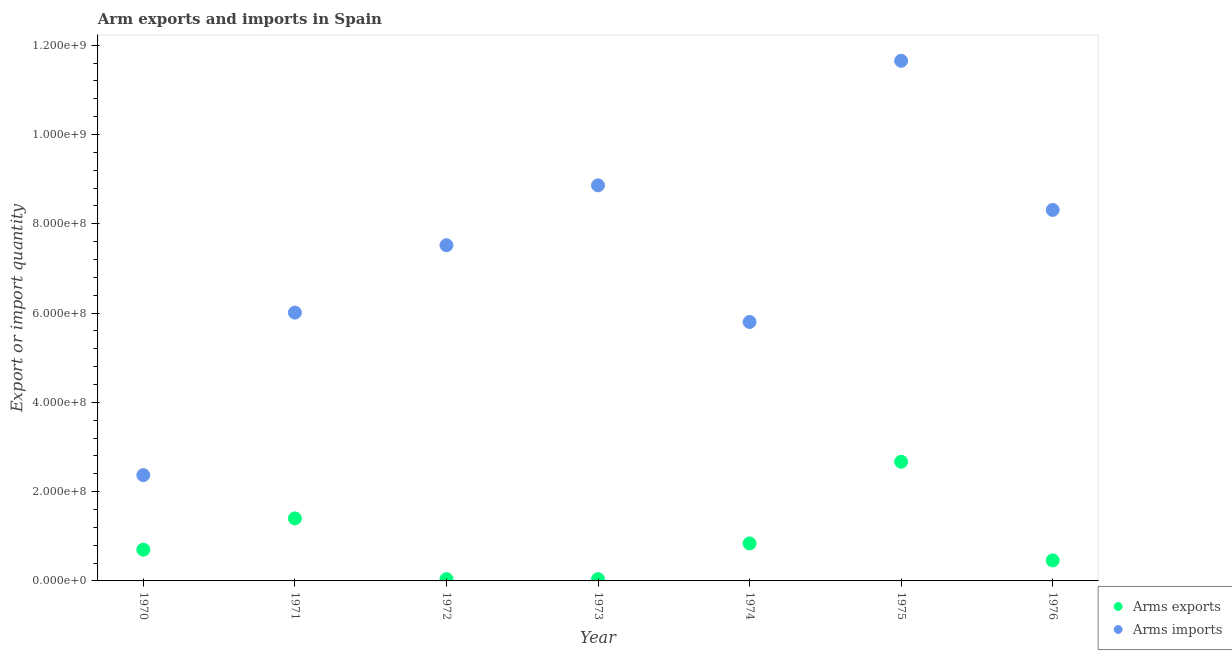Is the number of dotlines equal to the number of legend labels?
Your answer should be very brief. Yes. What is the arms exports in 1976?
Give a very brief answer. 4.60e+07. Across all years, what is the maximum arms imports?
Your answer should be very brief. 1.16e+09. Across all years, what is the minimum arms imports?
Your answer should be very brief. 2.37e+08. In which year was the arms imports maximum?
Give a very brief answer. 1975. What is the total arms exports in the graph?
Provide a short and direct response. 6.15e+08. What is the difference between the arms imports in 1972 and that in 1975?
Provide a succinct answer. -4.13e+08. What is the difference between the arms imports in 1973 and the arms exports in 1971?
Provide a short and direct response. 7.46e+08. What is the average arms imports per year?
Keep it short and to the point. 7.22e+08. In the year 1976, what is the difference between the arms imports and arms exports?
Make the answer very short. 7.85e+08. In how many years, is the arms imports greater than 440000000?
Offer a very short reply. 6. What is the ratio of the arms imports in 1972 to that in 1975?
Keep it short and to the point. 0.65. Is the arms exports in 1970 less than that in 1973?
Offer a very short reply. No. Is the difference between the arms imports in 1971 and 1976 greater than the difference between the arms exports in 1971 and 1976?
Provide a short and direct response. No. What is the difference between the highest and the second highest arms exports?
Your answer should be very brief. 1.27e+08. What is the difference between the highest and the lowest arms exports?
Your answer should be compact. 2.63e+08. In how many years, is the arms exports greater than the average arms exports taken over all years?
Provide a short and direct response. 2. Is the arms exports strictly less than the arms imports over the years?
Your answer should be compact. Yes. What is the difference between two consecutive major ticks on the Y-axis?
Your response must be concise. 2.00e+08. Are the values on the major ticks of Y-axis written in scientific E-notation?
Your answer should be compact. Yes. Where does the legend appear in the graph?
Your answer should be very brief. Bottom right. How are the legend labels stacked?
Your answer should be very brief. Vertical. What is the title of the graph?
Provide a succinct answer. Arm exports and imports in Spain. What is the label or title of the Y-axis?
Ensure brevity in your answer.  Export or import quantity. What is the Export or import quantity in Arms exports in 1970?
Give a very brief answer. 7.00e+07. What is the Export or import quantity of Arms imports in 1970?
Your response must be concise. 2.37e+08. What is the Export or import quantity of Arms exports in 1971?
Provide a short and direct response. 1.40e+08. What is the Export or import quantity in Arms imports in 1971?
Your answer should be very brief. 6.01e+08. What is the Export or import quantity of Arms imports in 1972?
Offer a very short reply. 7.52e+08. What is the Export or import quantity of Arms exports in 1973?
Offer a terse response. 4.00e+06. What is the Export or import quantity in Arms imports in 1973?
Make the answer very short. 8.86e+08. What is the Export or import quantity in Arms exports in 1974?
Keep it short and to the point. 8.40e+07. What is the Export or import quantity in Arms imports in 1974?
Ensure brevity in your answer.  5.80e+08. What is the Export or import quantity in Arms exports in 1975?
Your answer should be very brief. 2.67e+08. What is the Export or import quantity of Arms imports in 1975?
Give a very brief answer. 1.16e+09. What is the Export or import quantity in Arms exports in 1976?
Your answer should be very brief. 4.60e+07. What is the Export or import quantity of Arms imports in 1976?
Provide a short and direct response. 8.31e+08. Across all years, what is the maximum Export or import quantity in Arms exports?
Your answer should be compact. 2.67e+08. Across all years, what is the maximum Export or import quantity of Arms imports?
Offer a terse response. 1.16e+09. Across all years, what is the minimum Export or import quantity of Arms exports?
Your answer should be compact. 4.00e+06. Across all years, what is the minimum Export or import quantity of Arms imports?
Keep it short and to the point. 2.37e+08. What is the total Export or import quantity of Arms exports in the graph?
Offer a terse response. 6.15e+08. What is the total Export or import quantity of Arms imports in the graph?
Provide a short and direct response. 5.05e+09. What is the difference between the Export or import quantity in Arms exports in 1970 and that in 1971?
Your answer should be very brief. -7.00e+07. What is the difference between the Export or import quantity of Arms imports in 1970 and that in 1971?
Offer a terse response. -3.64e+08. What is the difference between the Export or import quantity of Arms exports in 1970 and that in 1972?
Make the answer very short. 6.60e+07. What is the difference between the Export or import quantity in Arms imports in 1970 and that in 1972?
Provide a succinct answer. -5.15e+08. What is the difference between the Export or import quantity of Arms exports in 1970 and that in 1973?
Your answer should be very brief. 6.60e+07. What is the difference between the Export or import quantity of Arms imports in 1970 and that in 1973?
Offer a terse response. -6.49e+08. What is the difference between the Export or import quantity of Arms exports in 1970 and that in 1974?
Keep it short and to the point. -1.40e+07. What is the difference between the Export or import quantity of Arms imports in 1970 and that in 1974?
Provide a succinct answer. -3.43e+08. What is the difference between the Export or import quantity in Arms exports in 1970 and that in 1975?
Keep it short and to the point. -1.97e+08. What is the difference between the Export or import quantity of Arms imports in 1970 and that in 1975?
Your answer should be compact. -9.28e+08. What is the difference between the Export or import quantity in Arms exports in 1970 and that in 1976?
Offer a terse response. 2.40e+07. What is the difference between the Export or import quantity of Arms imports in 1970 and that in 1976?
Provide a succinct answer. -5.94e+08. What is the difference between the Export or import quantity in Arms exports in 1971 and that in 1972?
Make the answer very short. 1.36e+08. What is the difference between the Export or import quantity of Arms imports in 1971 and that in 1972?
Offer a very short reply. -1.51e+08. What is the difference between the Export or import quantity in Arms exports in 1971 and that in 1973?
Make the answer very short. 1.36e+08. What is the difference between the Export or import quantity in Arms imports in 1971 and that in 1973?
Make the answer very short. -2.85e+08. What is the difference between the Export or import quantity in Arms exports in 1971 and that in 1974?
Keep it short and to the point. 5.60e+07. What is the difference between the Export or import quantity of Arms imports in 1971 and that in 1974?
Your answer should be compact. 2.10e+07. What is the difference between the Export or import quantity in Arms exports in 1971 and that in 1975?
Provide a short and direct response. -1.27e+08. What is the difference between the Export or import quantity of Arms imports in 1971 and that in 1975?
Your answer should be compact. -5.64e+08. What is the difference between the Export or import quantity in Arms exports in 1971 and that in 1976?
Give a very brief answer. 9.40e+07. What is the difference between the Export or import quantity of Arms imports in 1971 and that in 1976?
Give a very brief answer. -2.30e+08. What is the difference between the Export or import quantity in Arms exports in 1972 and that in 1973?
Offer a very short reply. 0. What is the difference between the Export or import quantity in Arms imports in 1972 and that in 1973?
Your answer should be very brief. -1.34e+08. What is the difference between the Export or import quantity of Arms exports in 1972 and that in 1974?
Provide a succinct answer. -8.00e+07. What is the difference between the Export or import quantity of Arms imports in 1972 and that in 1974?
Keep it short and to the point. 1.72e+08. What is the difference between the Export or import quantity of Arms exports in 1972 and that in 1975?
Your response must be concise. -2.63e+08. What is the difference between the Export or import quantity in Arms imports in 1972 and that in 1975?
Offer a very short reply. -4.13e+08. What is the difference between the Export or import quantity in Arms exports in 1972 and that in 1976?
Your answer should be very brief. -4.20e+07. What is the difference between the Export or import quantity of Arms imports in 1972 and that in 1976?
Provide a succinct answer. -7.90e+07. What is the difference between the Export or import quantity in Arms exports in 1973 and that in 1974?
Keep it short and to the point. -8.00e+07. What is the difference between the Export or import quantity of Arms imports in 1973 and that in 1974?
Offer a terse response. 3.06e+08. What is the difference between the Export or import quantity in Arms exports in 1973 and that in 1975?
Offer a very short reply. -2.63e+08. What is the difference between the Export or import quantity in Arms imports in 1973 and that in 1975?
Your response must be concise. -2.79e+08. What is the difference between the Export or import quantity of Arms exports in 1973 and that in 1976?
Make the answer very short. -4.20e+07. What is the difference between the Export or import quantity of Arms imports in 1973 and that in 1976?
Give a very brief answer. 5.50e+07. What is the difference between the Export or import quantity in Arms exports in 1974 and that in 1975?
Keep it short and to the point. -1.83e+08. What is the difference between the Export or import quantity in Arms imports in 1974 and that in 1975?
Your answer should be compact. -5.85e+08. What is the difference between the Export or import quantity in Arms exports in 1974 and that in 1976?
Your answer should be compact. 3.80e+07. What is the difference between the Export or import quantity of Arms imports in 1974 and that in 1976?
Your answer should be compact. -2.51e+08. What is the difference between the Export or import quantity in Arms exports in 1975 and that in 1976?
Offer a very short reply. 2.21e+08. What is the difference between the Export or import quantity in Arms imports in 1975 and that in 1976?
Provide a succinct answer. 3.34e+08. What is the difference between the Export or import quantity of Arms exports in 1970 and the Export or import quantity of Arms imports in 1971?
Your answer should be very brief. -5.31e+08. What is the difference between the Export or import quantity in Arms exports in 1970 and the Export or import quantity in Arms imports in 1972?
Your answer should be very brief. -6.82e+08. What is the difference between the Export or import quantity of Arms exports in 1970 and the Export or import quantity of Arms imports in 1973?
Provide a short and direct response. -8.16e+08. What is the difference between the Export or import quantity of Arms exports in 1970 and the Export or import quantity of Arms imports in 1974?
Offer a very short reply. -5.10e+08. What is the difference between the Export or import quantity of Arms exports in 1970 and the Export or import quantity of Arms imports in 1975?
Provide a short and direct response. -1.10e+09. What is the difference between the Export or import quantity of Arms exports in 1970 and the Export or import quantity of Arms imports in 1976?
Keep it short and to the point. -7.61e+08. What is the difference between the Export or import quantity in Arms exports in 1971 and the Export or import quantity in Arms imports in 1972?
Provide a succinct answer. -6.12e+08. What is the difference between the Export or import quantity in Arms exports in 1971 and the Export or import quantity in Arms imports in 1973?
Give a very brief answer. -7.46e+08. What is the difference between the Export or import quantity in Arms exports in 1971 and the Export or import quantity in Arms imports in 1974?
Offer a terse response. -4.40e+08. What is the difference between the Export or import quantity of Arms exports in 1971 and the Export or import quantity of Arms imports in 1975?
Your answer should be compact. -1.02e+09. What is the difference between the Export or import quantity of Arms exports in 1971 and the Export or import quantity of Arms imports in 1976?
Provide a succinct answer. -6.91e+08. What is the difference between the Export or import quantity of Arms exports in 1972 and the Export or import quantity of Arms imports in 1973?
Your response must be concise. -8.82e+08. What is the difference between the Export or import quantity in Arms exports in 1972 and the Export or import quantity in Arms imports in 1974?
Offer a terse response. -5.76e+08. What is the difference between the Export or import quantity of Arms exports in 1972 and the Export or import quantity of Arms imports in 1975?
Your answer should be compact. -1.16e+09. What is the difference between the Export or import quantity of Arms exports in 1972 and the Export or import quantity of Arms imports in 1976?
Your response must be concise. -8.27e+08. What is the difference between the Export or import quantity of Arms exports in 1973 and the Export or import quantity of Arms imports in 1974?
Offer a terse response. -5.76e+08. What is the difference between the Export or import quantity in Arms exports in 1973 and the Export or import quantity in Arms imports in 1975?
Your answer should be compact. -1.16e+09. What is the difference between the Export or import quantity of Arms exports in 1973 and the Export or import quantity of Arms imports in 1976?
Your answer should be very brief. -8.27e+08. What is the difference between the Export or import quantity in Arms exports in 1974 and the Export or import quantity in Arms imports in 1975?
Offer a terse response. -1.08e+09. What is the difference between the Export or import quantity in Arms exports in 1974 and the Export or import quantity in Arms imports in 1976?
Offer a very short reply. -7.47e+08. What is the difference between the Export or import quantity of Arms exports in 1975 and the Export or import quantity of Arms imports in 1976?
Give a very brief answer. -5.64e+08. What is the average Export or import quantity in Arms exports per year?
Your answer should be compact. 8.79e+07. What is the average Export or import quantity of Arms imports per year?
Give a very brief answer. 7.22e+08. In the year 1970, what is the difference between the Export or import quantity in Arms exports and Export or import quantity in Arms imports?
Provide a succinct answer. -1.67e+08. In the year 1971, what is the difference between the Export or import quantity of Arms exports and Export or import quantity of Arms imports?
Make the answer very short. -4.61e+08. In the year 1972, what is the difference between the Export or import quantity in Arms exports and Export or import quantity in Arms imports?
Your response must be concise. -7.48e+08. In the year 1973, what is the difference between the Export or import quantity of Arms exports and Export or import quantity of Arms imports?
Make the answer very short. -8.82e+08. In the year 1974, what is the difference between the Export or import quantity in Arms exports and Export or import quantity in Arms imports?
Ensure brevity in your answer.  -4.96e+08. In the year 1975, what is the difference between the Export or import quantity of Arms exports and Export or import quantity of Arms imports?
Keep it short and to the point. -8.98e+08. In the year 1976, what is the difference between the Export or import quantity of Arms exports and Export or import quantity of Arms imports?
Your answer should be very brief. -7.85e+08. What is the ratio of the Export or import quantity of Arms imports in 1970 to that in 1971?
Your answer should be compact. 0.39. What is the ratio of the Export or import quantity in Arms imports in 1970 to that in 1972?
Your answer should be compact. 0.32. What is the ratio of the Export or import quantity in Arms imports in 1970 to that in 1973?
Ensure brevity in your answer.  0.27. What is the ratio of the Export or import quantity in Arms imports in 1970 to that in 1974?
Give a very brief answer. 0.41. What is the ratio of the Export or import quantity of Arms exports in 1970 to that in 1975?
Offer a very short reply. 0.26. What is the ratio of the Export or import quantity of Arms imports in 1970 to that in 1975?
Make the answer very short. 0.2. What is the ratio of the Export or import quantity in Arms exports in 1970 to that in 1976?
Your response must be concise. 1.52. What is the ratio of the Export or import quantity of Arms imports in 1970 to that in 1976?
Your answer should be very brief. 0.29. What is the ratio of the Export or import quantity in Arms imports in 1971 to that in 1972?
Ensure brevity in your answer.  0.8. What is the ratio of the Export or import quantity of Arms imports in 1971 to that in 1973?
Give a very brief answer. 0.68. What is the ratio of the Export or import quantity of Arms exports in 1971 to that in 1974?
Your answer should be compact. 1.67. What is the ratio of the Export or import quantity of Arms imports in 1971 to that in 1974?
Your answer should be compact. 1.04. What is the ratio of the Export or import quantity in Arms exports in 1971 to that in 1975?
Give a very brief answer. 0.52. What is the ratio of the Export or import quantity of Arms imports in 1971 to that in 1975?
Keep it short and to the point. 0.52. What is the ratio of the Export or import quantity of Arms exports in 1971 to that in 1976?
Offer a very short reply. 3.04. What is the ratio of the Export or import quantity in Arms imports in 1971 to that in 1976?
Keep it short and to the point. 0.72. What is the ratio of the Export or import quantity of Arms exports in 1972 to that in 1973?
Your answer should be very brief. 1. What is the ratio of the Export or import quantity in Arms imports in 1972 to that in 1973?
Give a very brief answer. 0.85. What is the ratio of the Export or import quantity of Arms exports in 1972 to that in 1974?
Give a very brief answer. 0.05. What is the ratio of the Export or import quantity in Arms imports in 1972 to that in 1974?
Make the answer very short. 1.3. What is the ratio of the Export or import quantity of Arms exports in 1972 to that in 1975?
Your response must be concise. 0.01. What is the ratio of the Export or import quantity of Arms imports in 1972 to that in 1975?
Offer a terse response. 0.65. What is the ratio of the Export or import quantity in Arms exports in 1972 to that in 1976?
Your answer should be very brief. 0.09. What is the ratio of the Export or import quantity of Arms imports in 1972 to that in 1976?
Offer a very short reply. 0.9. What is the ratio of the Export or import quantity in Arms exports in 1973 to that in 1974?
Your answer should be very brief. 0.05. What is the ratio of the Export or import quantity in Arms imports in 1973 to that in 1974?
Offer a very short reply. 1.53. What is the ratio of the Export or import quantity in Arms exports in 1973 to that in 1975?
Provide a short and direct response. 0.01. What is the ratio of the Export or import quantity of Arms imports in 1973 to that in 1975?
Make the answer very short. 0.76. What is the ratio of the Export or import quantity of Arms exports in 1973 to that in 1976?
Provide a succinct answer. 0.09. What is the ratio of the Export or import quantity of Arms imports in 1973 to that in 1976?
Your answer should be very brief. 1.07. What is the ratio of the Export or import quantity in Arms exports in 1974 to that in 1975?
Provide a short and direct response. 0.31. What is the ratio of the Export or import quantity of Arms imports in 1974 to that in 1975?
Your answer should be compact. 0.5. What is the ratio of the Export or import quantity in Arms exports in 1974 to that in 1976?
Make the answer very short. 1.83. What is the ratio of the Export or import quantity of Arms imports in 1974 to that in 1976?
Your answer should be very brief. 0.7. What is the ratio of the Export or import quantity in Arms exports in 1975 to that in 1976?
Your answer should be compact. 5.8. What is the ratio of the Export or import quantity of Arms imports in 1975 to that in 1976?
Keep it short and to the point. 1.4. What is the difference between the highest and the second highest Export or import quantity of Arms exports?
Offer a very short reply. 1.27e+08. What is the difference between the highest and the second highest Export or import quantity of Arms imports?
Make the answer very short. 2.79e+08. What is the difference between the highest and the lowest Export or import quantity in Arms exports?
Your answer should be compact. 2.63e+08. What is the difference between the highest and the lowest Export or import quantity of Arms imports?
Offer a terse response. 9.28e+08. 